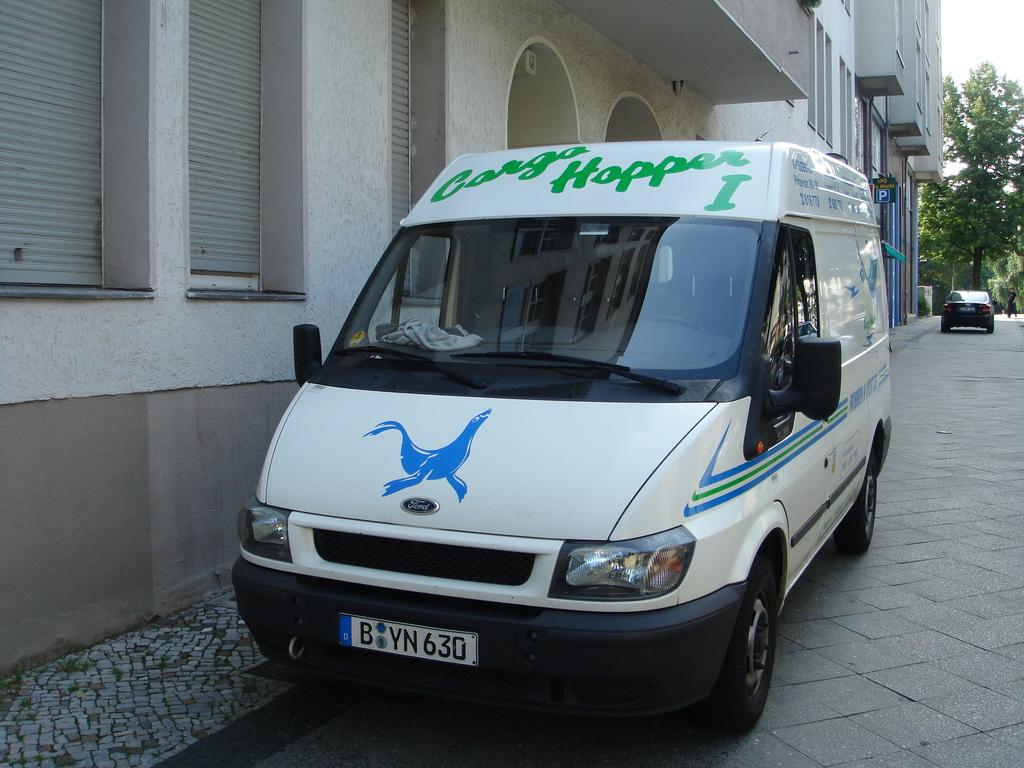<image>
Summarize the visual content of the image. Cargo hopper van is parked on the side of the road 